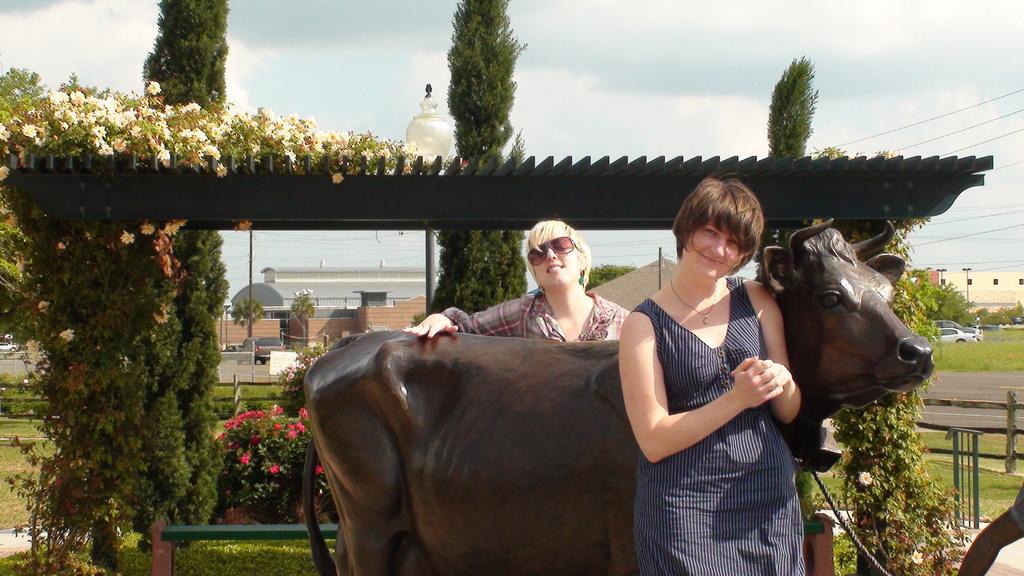In one or two sentences, can you explain what this image depicts? In this image, at the right side we can see a statue of a cow, there are two women standing at the statue, there is a shed and there are some trees, in the background there are some buildings and at the top there is a sky. 